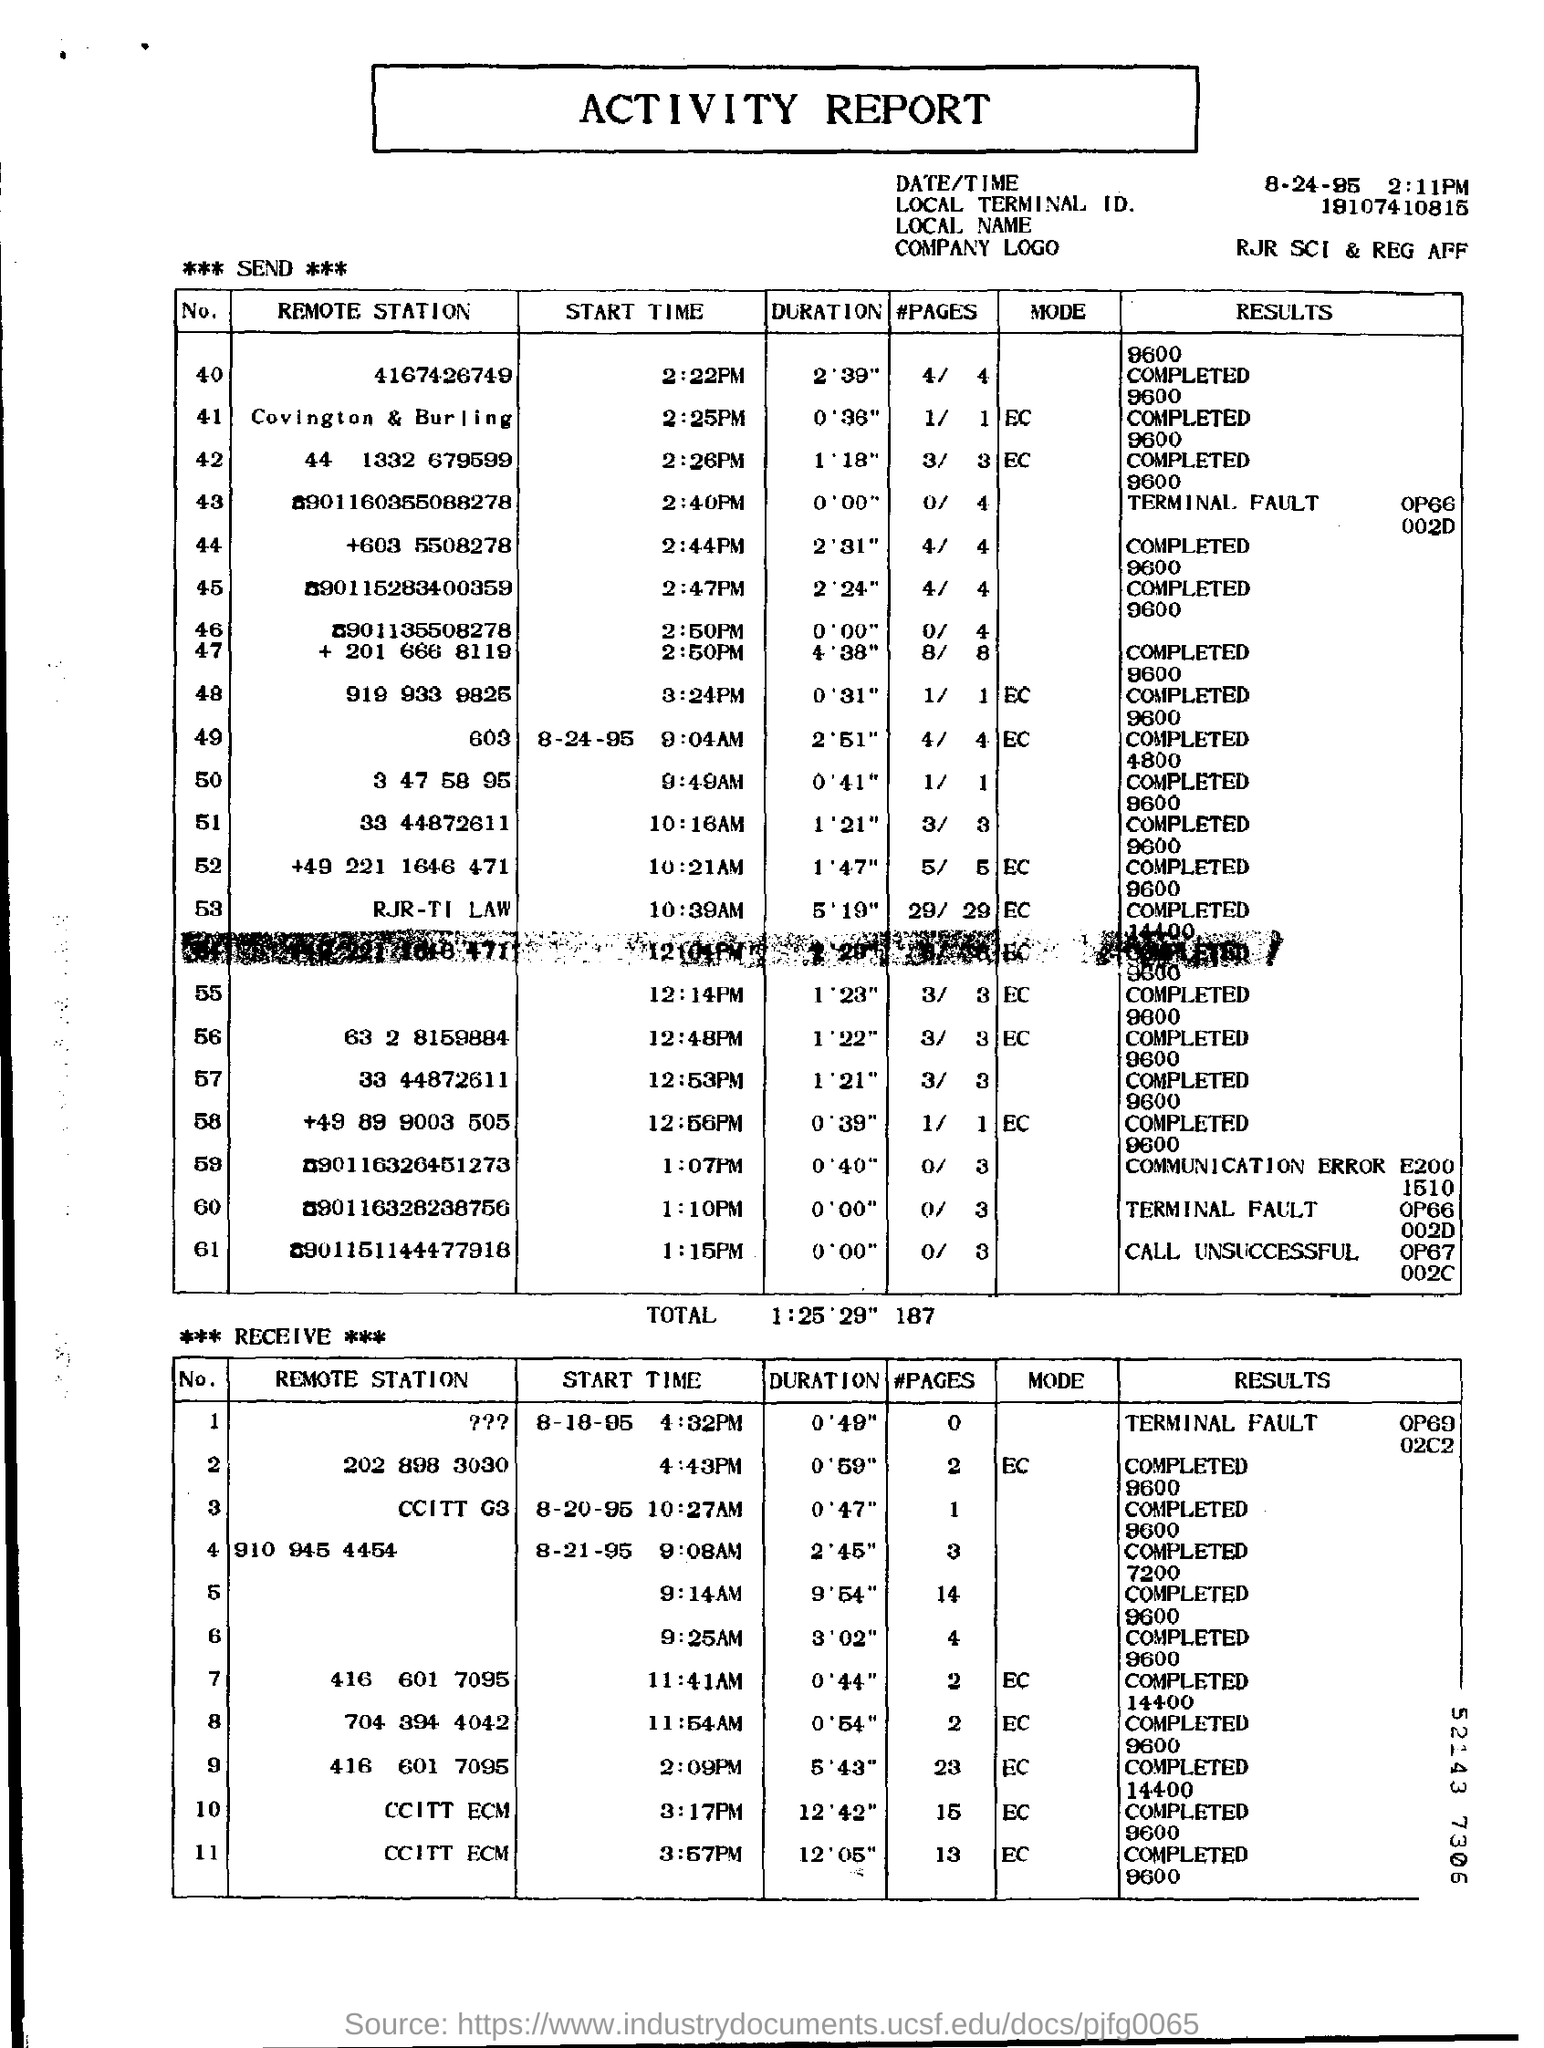What is the duration of Remote Station 4167426749?
Provide a short and direct response. 2.39. 